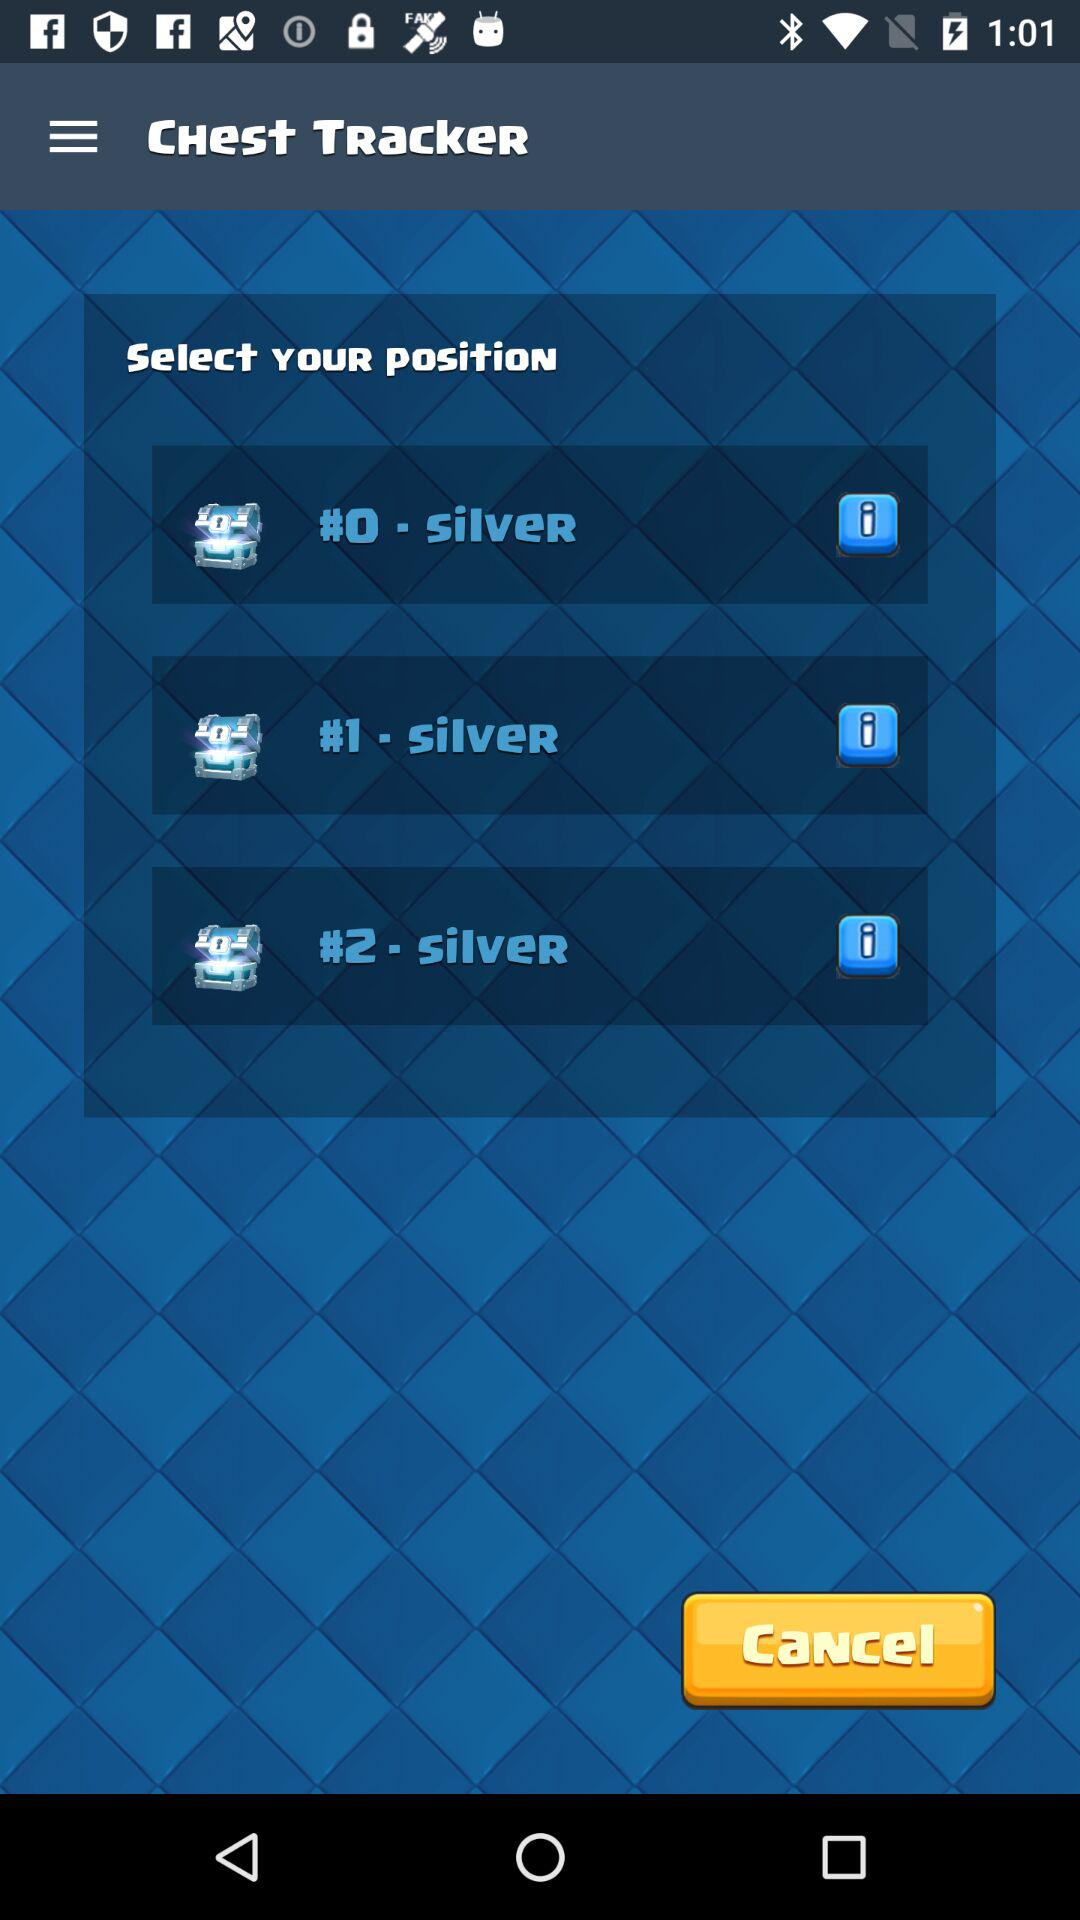What are the different positions? The different positions are "#0-SilVeR", "#1-SilVeR", and "#2-SilVeR". 